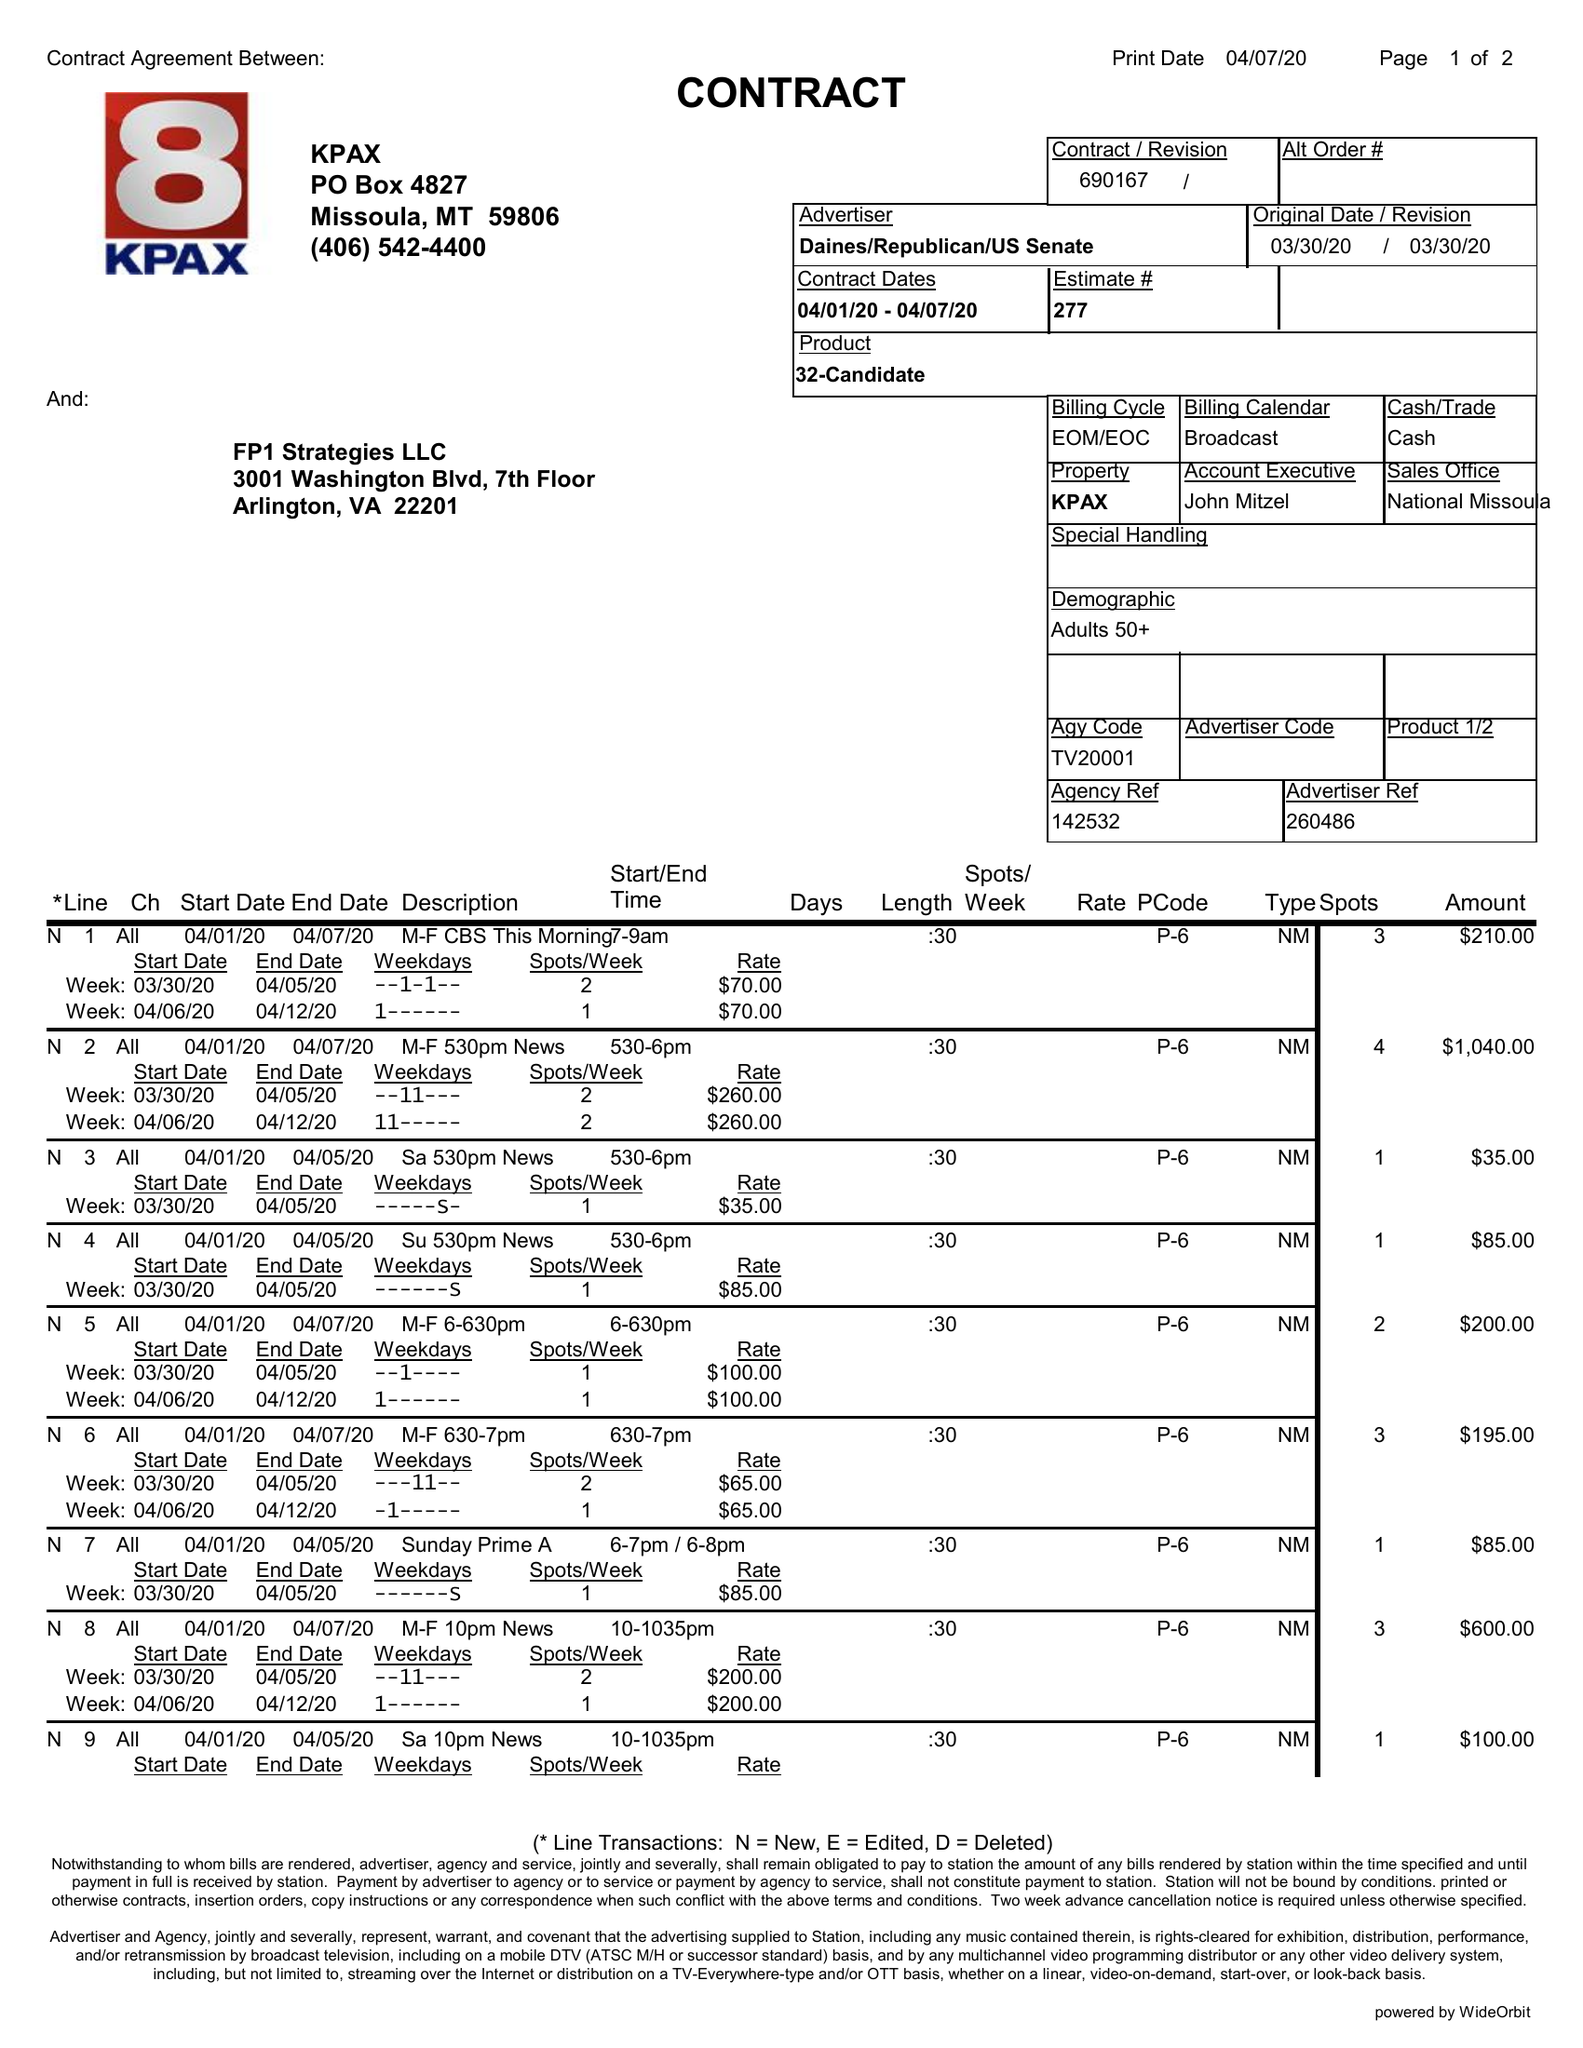What is the value for the flight_to?
Answer the question using a single word or phrase. 04/07/20 